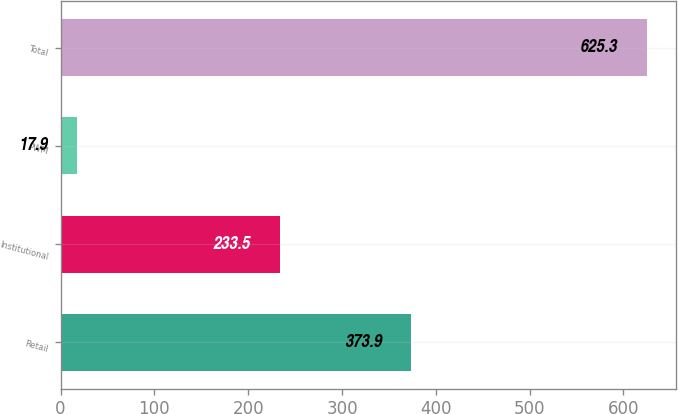Convert chart. <chart><loc_0><loc_0><loc_500><loc_500><bar_chart><fcel>Retail<fcel>Institutional<fcel>PWM<fcel>Total<nl><fcel>373.9<fcel>233.5<fcel>17.9<fcel>625.3<nl></chart> 